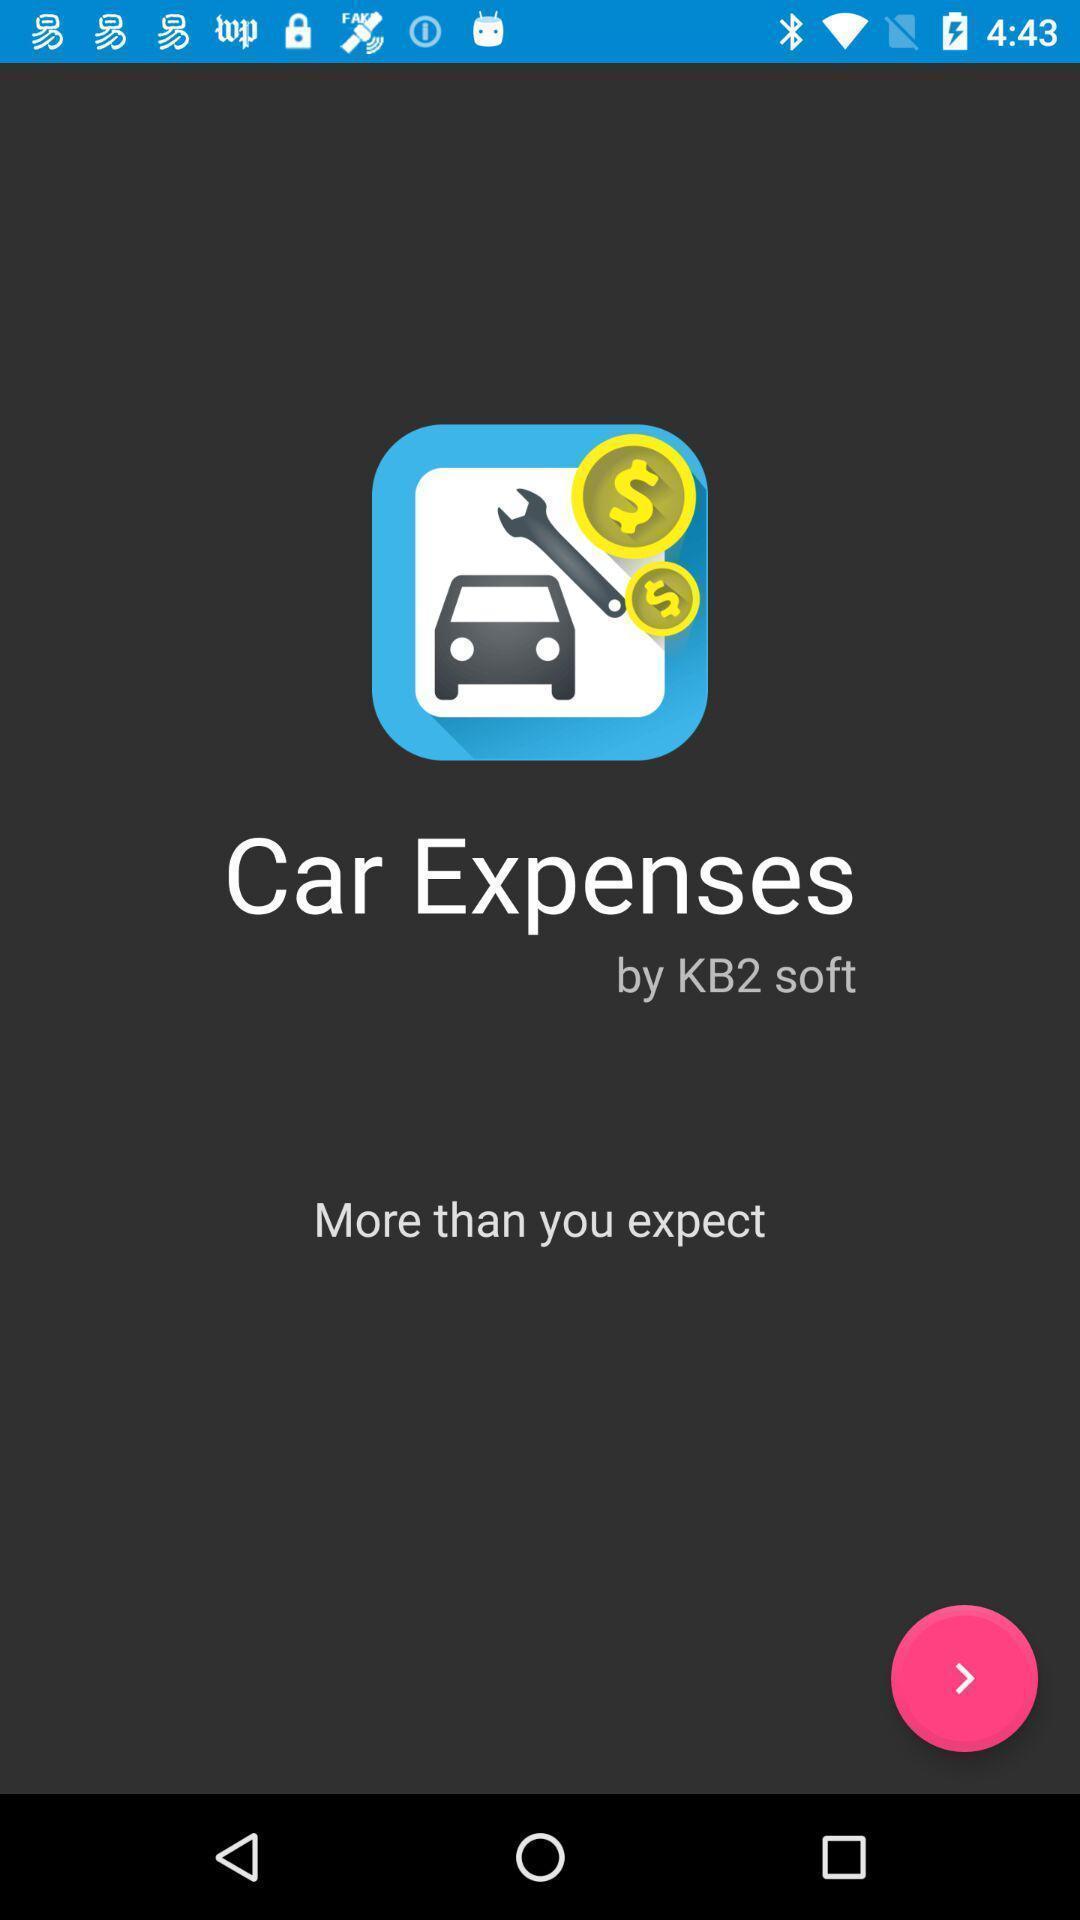Provide a detailed account of this screenshot. Welcome page for an expenses tracking app. 